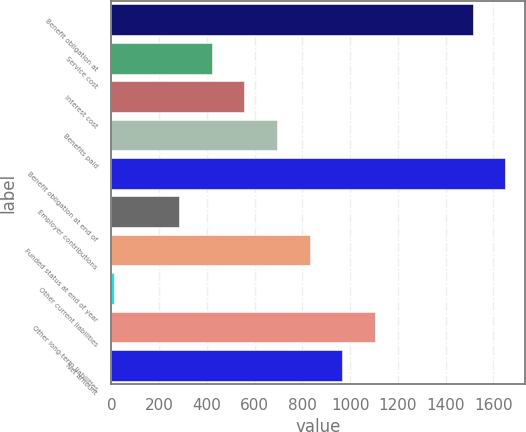Convert chart to OTSL. <chart><loc_0><loc_0><loc_500><loc_500><bar_chart><fcel>Benefit obligation at<fcel>Service cost<fcel>Interest cost<fcel>Benefits paid<fcel>Benefit obligation at end of<fcel>Employer contributions<fcel>Funded status at end of year<fcel>Other current liabilities<fcel>Other long-term liabilities<fcel>Net amount<nl><fcel>1513.7<fcel>420.1<fcel>556.8<fcel>693.5<fcel>1650.4<fcel>283.4<fcel>830.2<fcel>10<fcel>1103.6<fcel>966.9<nl></chart> 